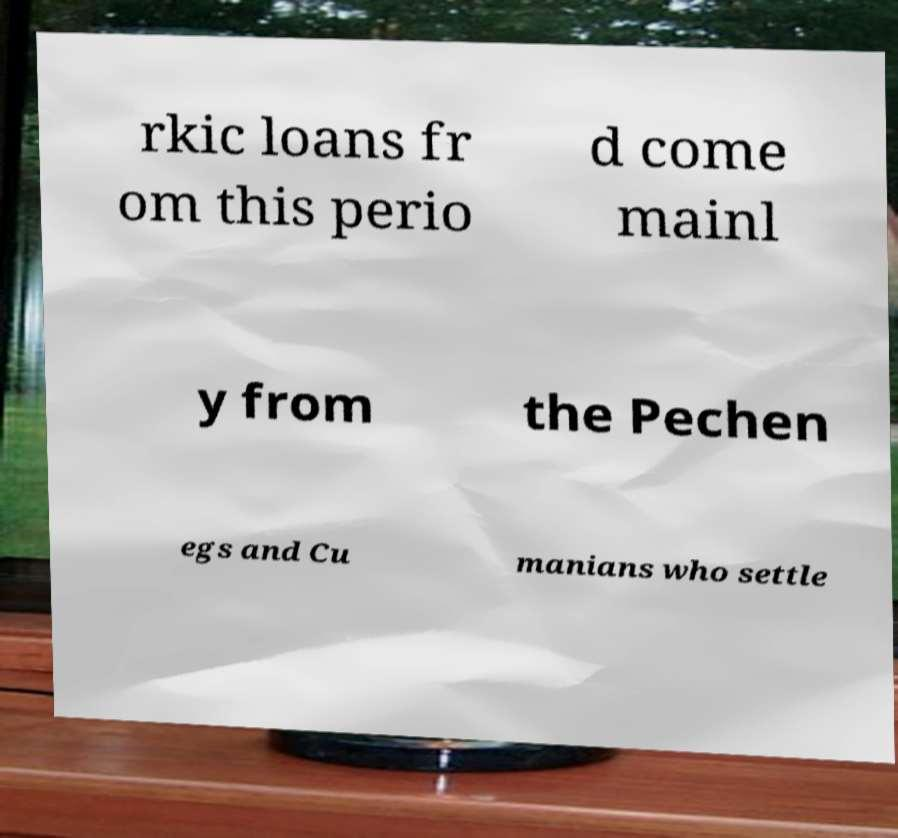Could you assist in decoding the text presented in this image and type it out clearly? rkic loans fr om this perio d come mainl y from the Pechen egs and Cu manians who settle 